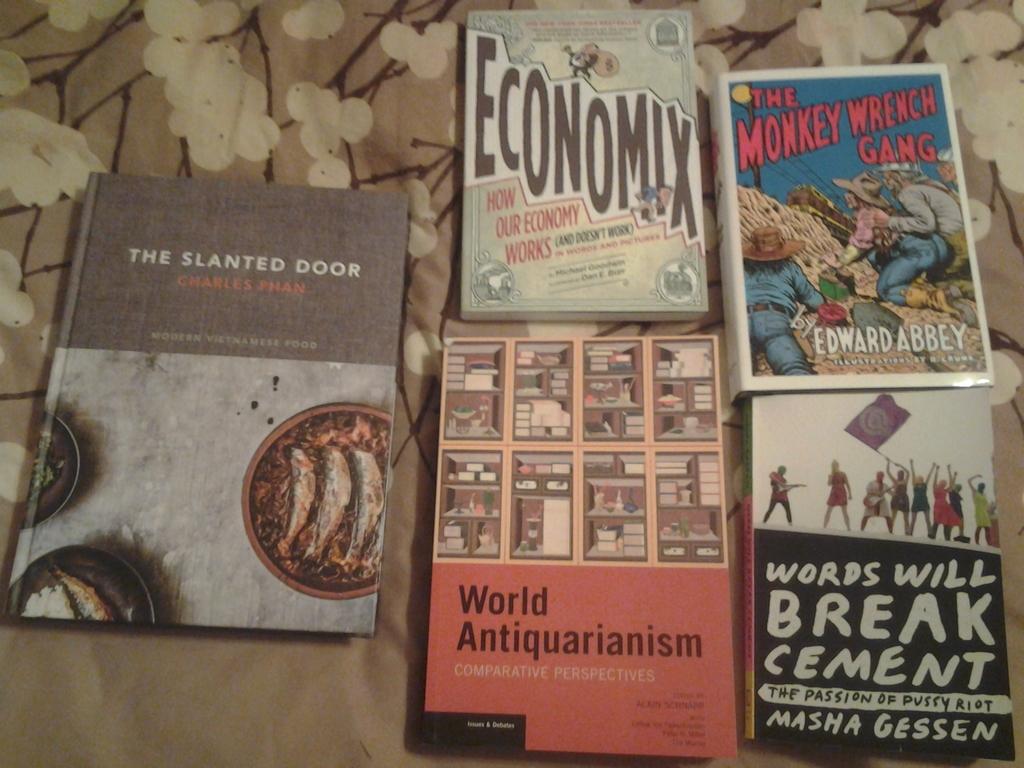What will words break?
Keep it short and to the point. Cement. What is the name of the gang on the book?
Keep it short and to the point. The monkey wrench gang. 